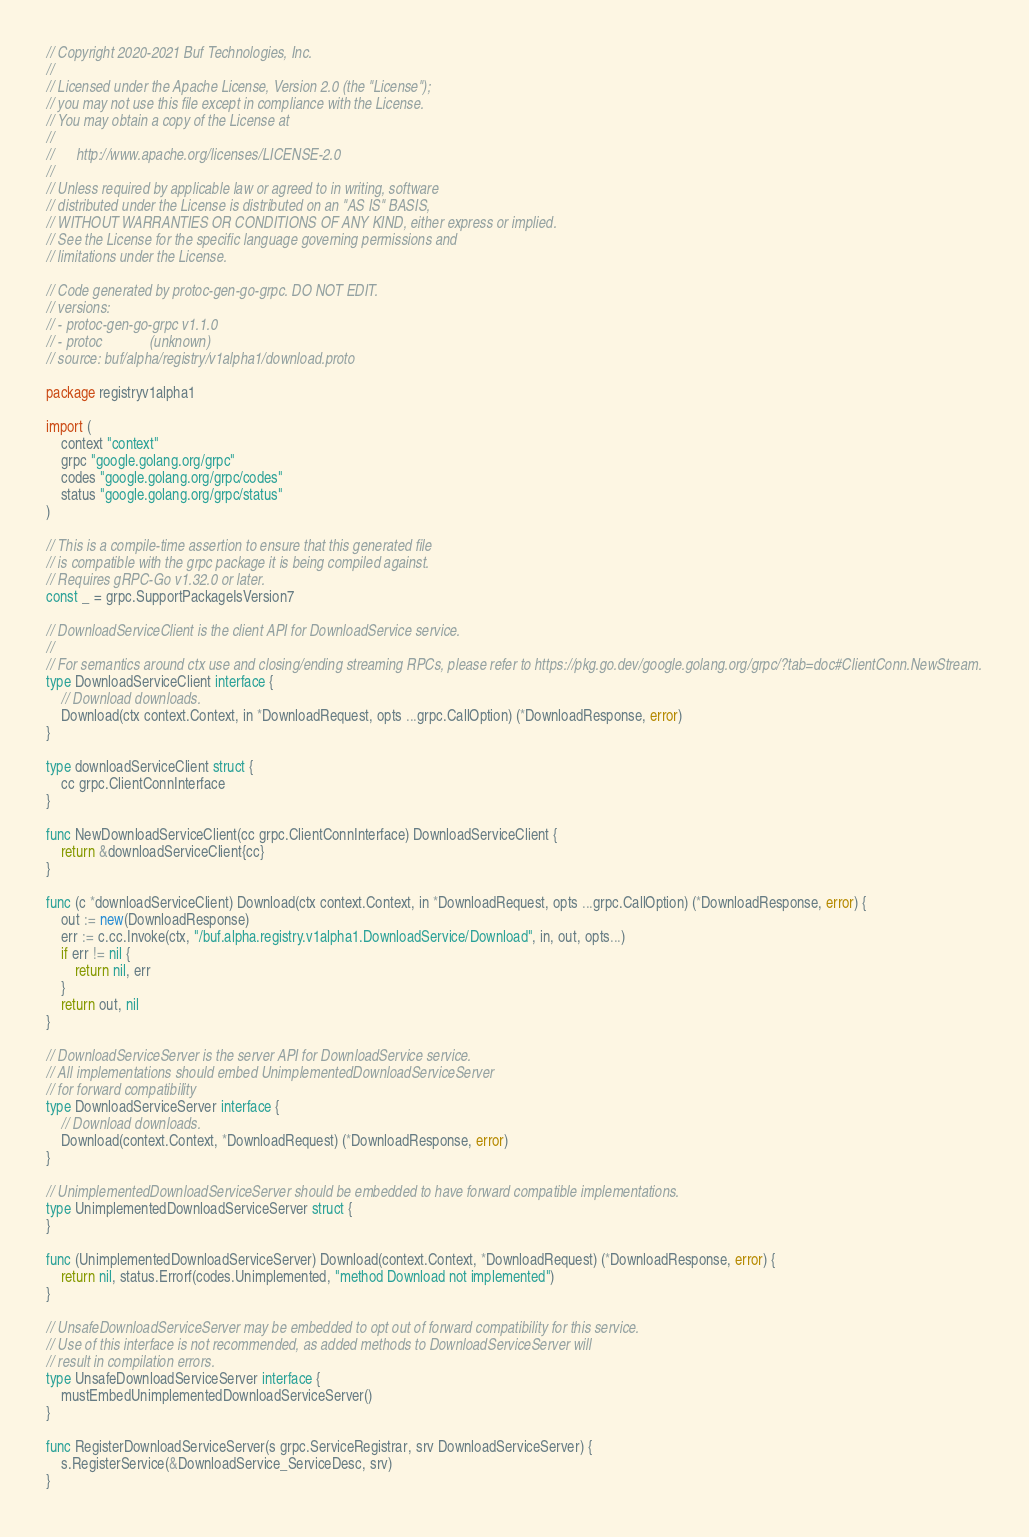<code> <loc_0><loc_0><loc_500><loc_500><_Go_>// Copyright 2020-2021 Buf Technologies, Inc.
//
// Licensed under the Apache License, Version 2.0 (the "License");
// you may not use this file except in compliance with the License.
// You may obtain a copy of the License at
//
//      http://www.apache.org/licenses/LICENSE-2.0
//
// Unless required by applicable law or agreed to in writing, software
// distributed under the License is distributed on an "AS IS" BASIS,
// WITHOUT WARRANTIES OR CONDITIONS OF ANY KIND, either express or implied.
// See the License for the specific language governing permissions and
// limitations under the License.

// Code generated by protoc-gen-go-grpc. DO NOT EDIT.
// versions:
// - protoc-gen-go-grpc v1.1.0
// - protoc             (unknown)
// source: buf/alpha/registry/v1alpha1/download.proto

package registryv1alpha1

import (
	context "context"
	grpc "google.golang.org/grpc"
	codes "google.golang.org/grpc/codes"
	status "google.golang.org/grpc/status"
)

// This is a compile-time assertion to ensure that this generated file
// is compatible with the grpc package it is being compiled against.
// Requires gRPC-Go v1.32.0 or later.
const _ = grpc.SupportPackageIsVersion7

// DownloadServiceClient is the client API for DownloadService service.
//
// For semantics around ctx use and closing/ending streaming RPCs, please refer to https://pkg.go.dev/google.golang.org/grpc/?tab=doc#ClientConn.NewStream.
type DownloadServiceClient interface {
	// Download downloads.
	Download(ctx context.Context, in *DownloadRequest, opts ...grpc.CallOption) (*DownloadResponse, error)
}

type downloadServiceClient struct {
	cc grpc.ClientConnInterface
}

func NewDownloadServiceClient(cc grpc.ClientConnInterface) DownloadServiceClient {
	return &downloadServiceClient{cc}
}

func (c *downloadServiceClient) Download(ctx context.Context, in *DownloadRequest, opts ...grpc.CallOption) (*DownloadResponse, error) {
	out := new(DownloadResponse)
	err := c.cc.Invoke(ctx, "/buf.alpha.registry.v1alpha1.DownloadService/Download", in, out, opts...)
	if err != nil {
		return nil, err
	}
	return out, nil
}

// DownloadServiceServer is the server API for DownloadService service.
// All implementations should embed UnimplementedDownloadServiceServer
// for forward compatibility
type DownloadServiceServer interface {
	// Download downloads.
	Download(context.Context, *DownloadRequest) (*DownloadResponse, error)
}

// UnimplementedDownloadServiceServer should be embedded to have forward compatible implementations.
type UnimplementedDownloadServiceServer struct {
}

func (UnimplementedDownloadServiceServer) Download(context.Context, *DownloadRequest) (*DownloadResponse, error) {
	return nil, status.Errorf(codes.Unimplemented, "method Download not implemented")
}

// UnsafeDownloadServiceServer may be embedded to opt out of forward compatibility for this service.
// Use of this interface is not recommended, as added methods to DownloadServiceServer will
// result in compilation errors.
type UnsafeDownloadServiceServer interface {
	mustEmbedUnimplementedDownloadServiceServer()
}

func RegisterDownloadServiceServer(s grpc.ServiceRegistrar, srv DownloadServiceServer) {
	s.RegisterService(&DownloadService_ServiceDesc, srv)
}
</code> 